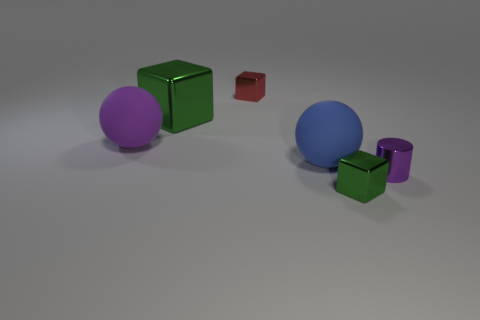Subtract all small red metallic cubes. How many cubes are left? 2 Subtract all blue spheres. How many spheres are left? 1 Add 4 red rubber cubes. How many objects exist? 10 Subtract all purple balls. How many green cubes are left? 2 Subtract 0 gray blocks. How many objects are left? 6 Subtract all cylinders. How many objects are left? 5 Subtract 1 cylinders. How many cylinders are left? 0 Subtract all cyan cubes. Subtract all brown cylinders. How many cubes are left? 3 Subtract all green matte spheres. Subtract all small purple shiny objects. How many objects are left? 5 Add 1 red metallic cubes. How many red metallic cubes are left? 2 